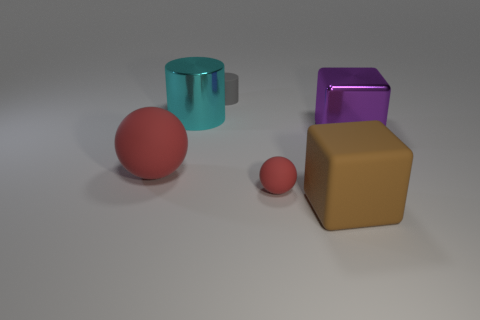Does the big matte sphere have the same color as the tiny sphere?
Keep it short and to the point. Yes. The metallic object that is left of the tiny object behind the purple cube is what color?
Give a very brief answer. Cyan. The red sphere in front of the big matte thing that is on the left side of the big brown thing that is on the left side of the large purple object is made of what material?
Your answer should be very brief. Rubber. Is the size of the metallic object behind the purple thing the same as the big red matte object?
Provide a succinct answer. Yes. What is the material of the big thing behind the purple metallic object?
Ensure brevity in your answer.  Metal. Are there more large shiny cubes than shiny objects?
Provide a short and direct response. No. How many objects are either big cylinders that are behind the tiny red matte thing or tiny rubber balls?
Your answer should be very brief. 2. There is a large rubber block to the right of the big matte sphere; what number of objects are to the left of it?
Ensure brevity in your answer.  4. There is a block to the left of the big block that is behind the large rubber object that is on the right side of the gray matte thing; what is its size?
Offer a very short reply. Large. There is a tiny thing that is in front of the large purple metal block; does it have the same color as the big ball?
Offer a terse response. Yes. 